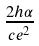<formula> <loc_0><loc_0><loc_500><loc_500>\frac { 2 h \alpha } { c e ^ { 2 } }</formula> 